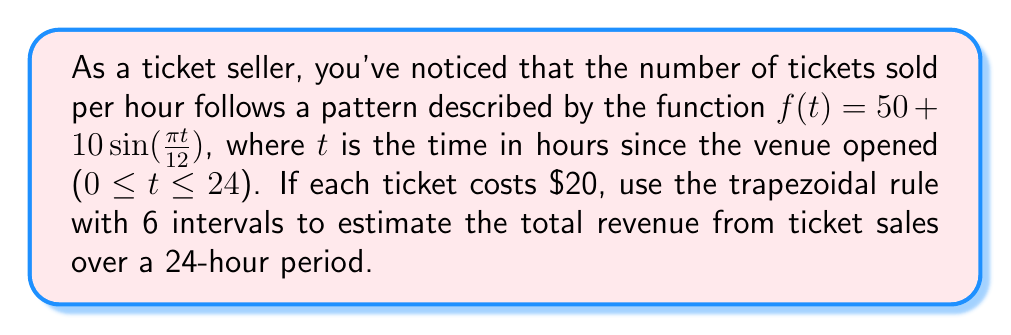What is the answer to this math problem? To solve this problem, we'll use the trapezoidal rule for numerical integration:

1) The formula for the trapezoidal rule with n intervals is:

   $$\int_{a}^{b} f(x) dx \approx \frac{h}{2}[f(x_0) + 2f(x_1) + 2f(x_2) + ... + 2f(x_{n-1}) + f(x_n)]$$

   where $h = \frac{b-a}{n}$, and $x_i = a + ih$ for $i = 0, 1, ..., n$

2) In our case:
   $a = 0$, $b = 24$, $n = 6$, so $h = \frac{24-0}{6} = 4$

3) We need to calculate $f(t)$ for $t = 0, 4, 8, 12, 16, 20, 24$:

   $f(0) = 50 + 10\sin(0) = 50$
   $f(4) = 50 + 10\sin(\frac{\pi}{3}) \approx 58.66$
   $f(8) = 50 + 10\sin(\frac{2\pi}{3}) \approx 58.66$
   $f(12) = 50 + 10\sin(\pi) = 50$
   $f(16) = 50 + 10\sin(\frac{4\pi}{3}) \approx 41.34$
   $f(20) = 50 + 10\sin(\frac{5\pi}{3}) \approx 41.34$
   $f(24) = 50 + 10\sin(2\pi) = 50$

4) Applying the trapezoidal rule:

   $$\int_{0}^{24} f(t) dt \approx \frac{4}{2}[50 + 2(58.66 + 58.66 + 50 + 41.34 + 41.34) + 50]$$
   $$\approx 2[50 + 2(250) + 50] = 2[50 + 500 + 50] = 1200$$

5) This gives us the total number of tickets sold over 24 hours. To get the revenue, multiply by the ticket price:

   Revenue = 1200 * $20 = $24,000
Answer: $24,000 